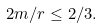Convert formula to latex. <formula><loc_0><loc_0><loc_500><loc_500>2 m / r \leq 2 / 3 .</formula> 